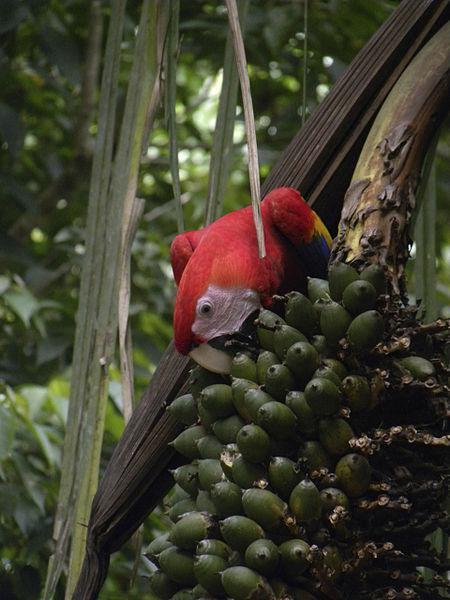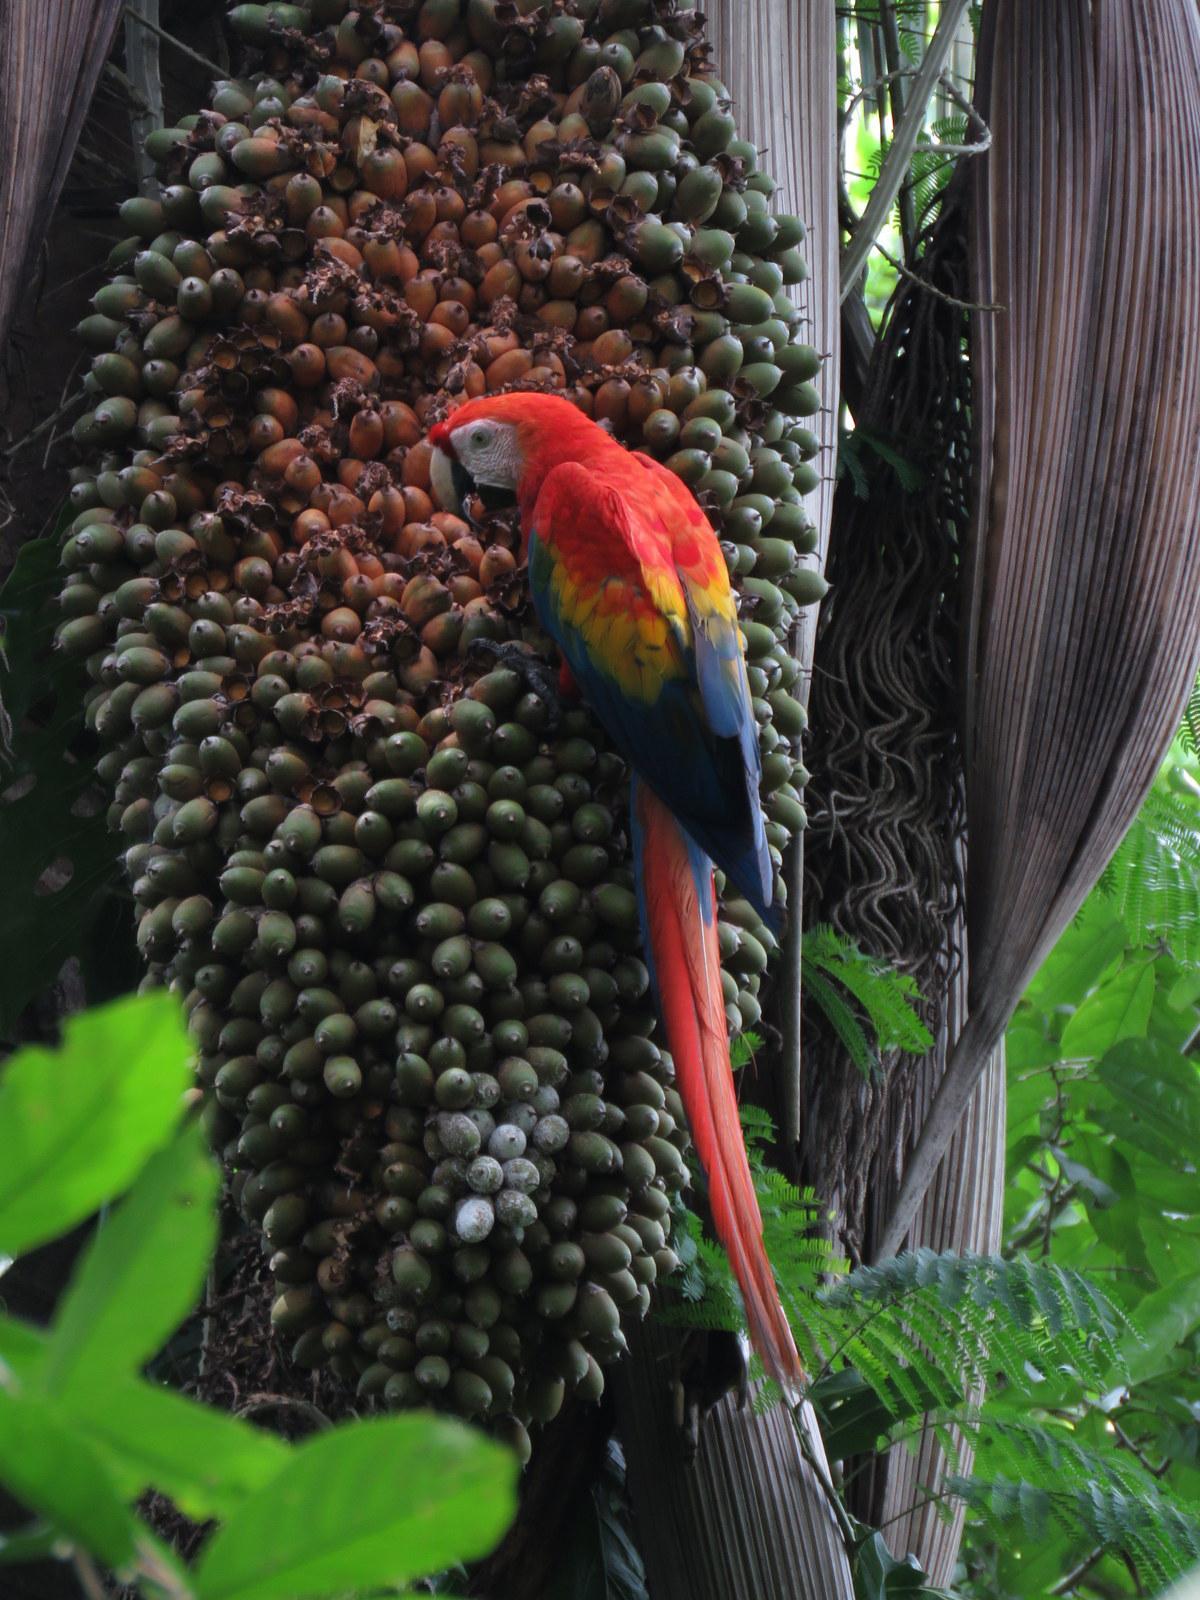The first image is the image on the left, the second image is the image on the right. For the images shown, is this caption "There are exactly two birds in total." true? Answer yes or no. Yes. 